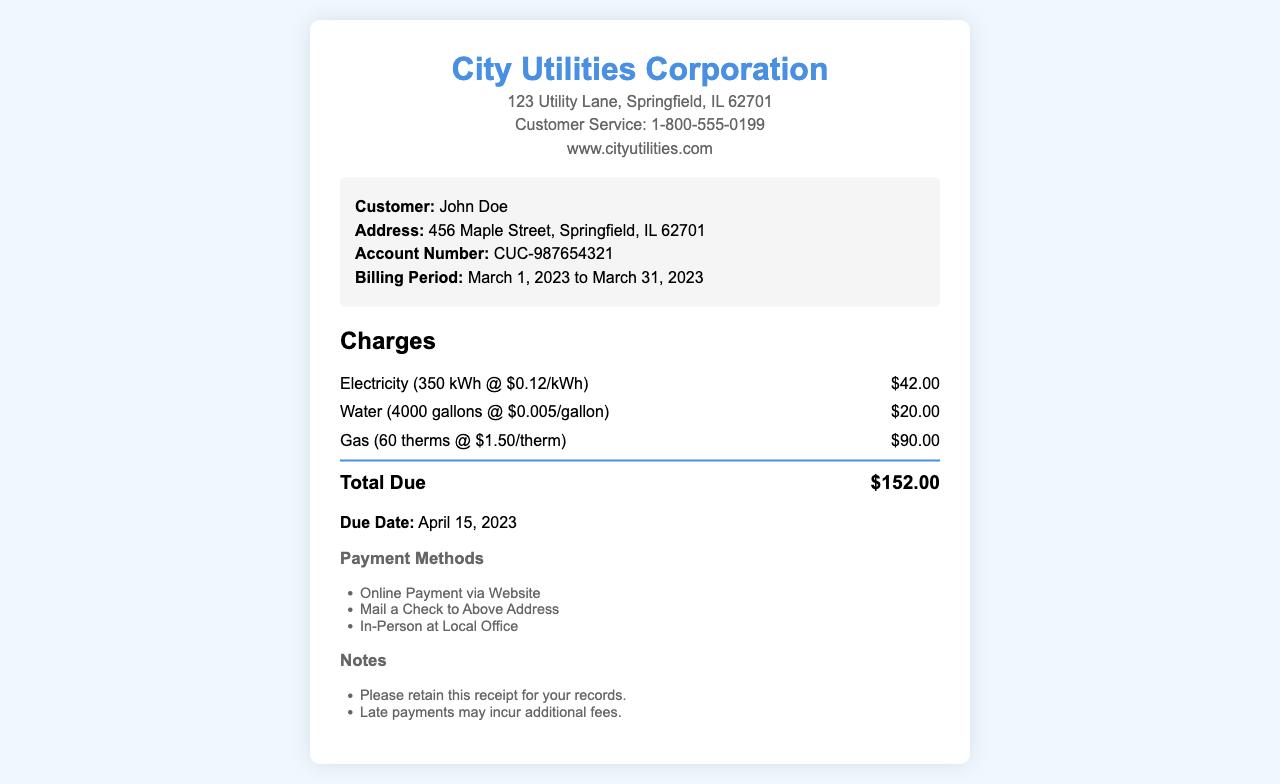What is the total due for this utility bill? The total due is listed at the end of the charges section as the sum of all charges: $42.00 + $20.00 + $90.00 = $152.00.
Answer: $152.00 What is the billing period for this receipt? The billing period is specified in the customer information section, detailing the start and end dates.
Answer: March 1, 2023 to March 31, 2023 Who is the customer listed on this receipt? The customer's name is provided in the customer information section.
Answer: John Doe What is the charge for gas services? The charge for gas services is found in the charges section related to gas usage.
Answer: $90.00 What is the address for the City Utilities Corporation? The address is provided in the header section of the receipt.
Answer: 123 Utility Lane, Springfield, IL 62701 What is the due date for this bill? The due date is mentioned at the bottom of the document.
Answer: April 15, 2023 How many gallons of water were used? The water usage is detailed in the charges section specifying the amount and corresponding charge.
Answer: 4000 gallons What payment methods are listed? Payment methods are provided in a specific section, detailing available options for payment.
Answer: Online Payment via Website, Mail a Check to Above Address, In-Person at Local Office What is the account number for the customer? The account number is included in the customer information section of the receipt.
Answer: CUC-987654321 